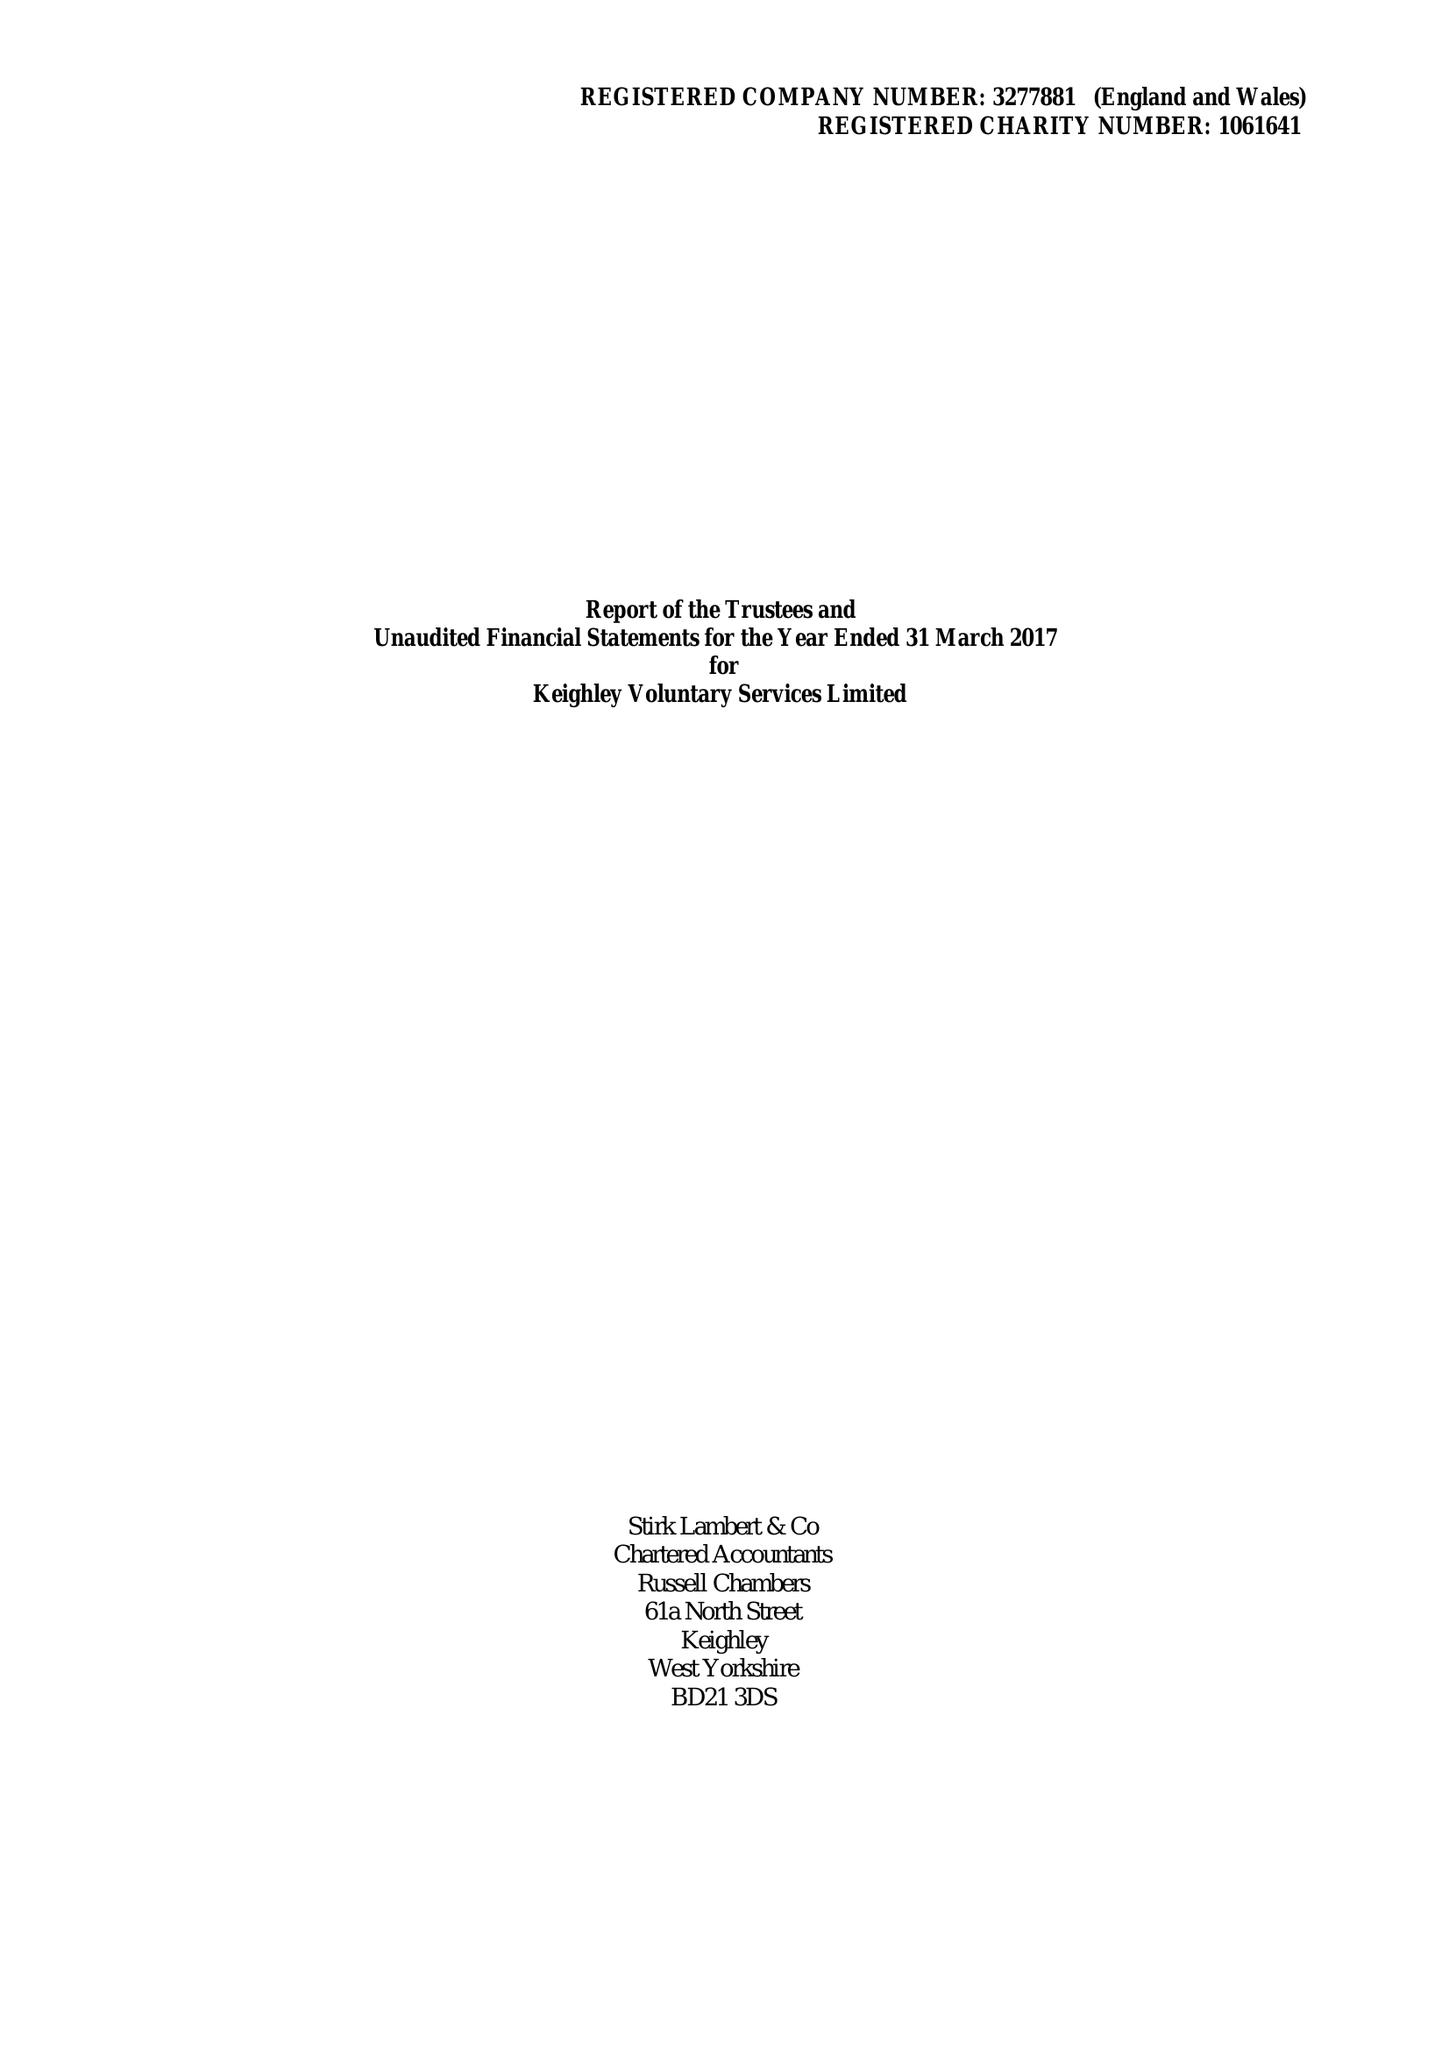What is the value for the charity_name?
Answer the question using a single word or phrase. Keighley Voluntary Service Ltd. 